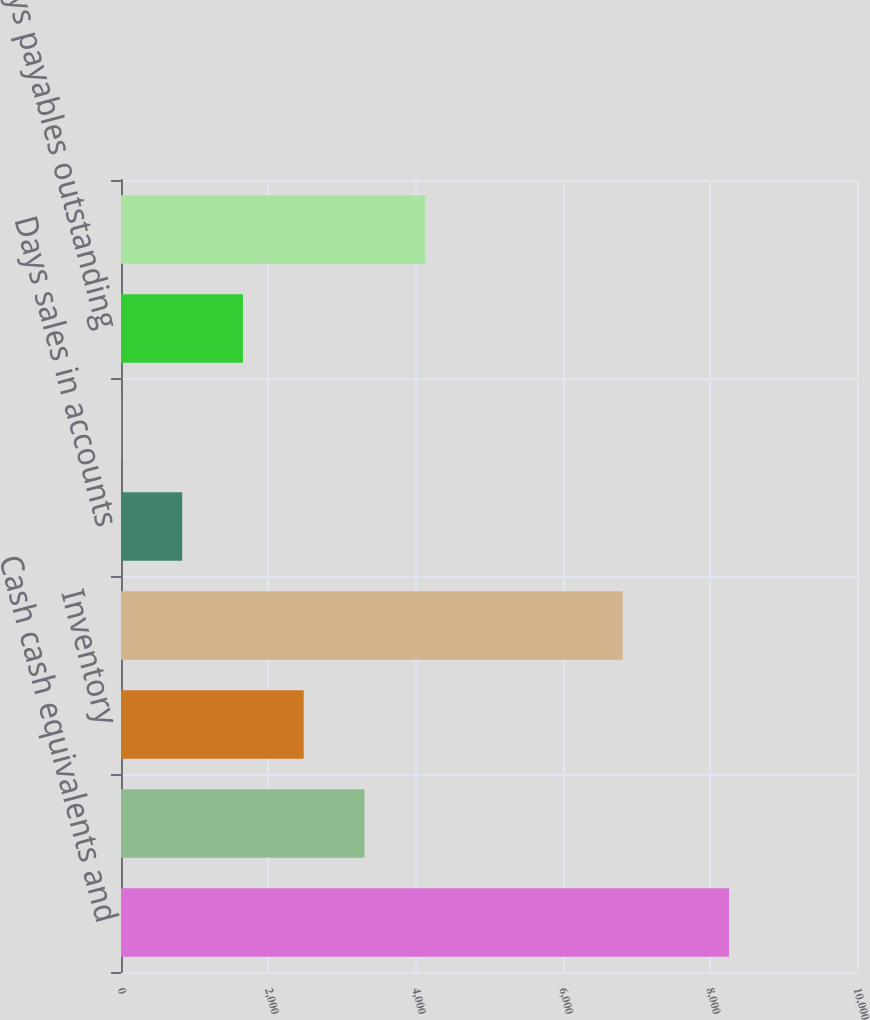Convert chart. <chart><loc_0><loc_0><loc_500><loc_500><bar_chart><fcel>Cash cash equivalents and<fcel>Accounts receivable net<fcel>Inventory<fcel>Working capital<fcel>Days sales in accounts<fcel>Days of supply in inventory<fcel>Days payables outstanding<fcel>Annual operating cash flow<nl><fcel>8261<fcel>3308<fcel>2482.5<fcel>6816<fcel>831.5<fcel>6<fcel>1657<fcel>4133.5<nl></chart> 